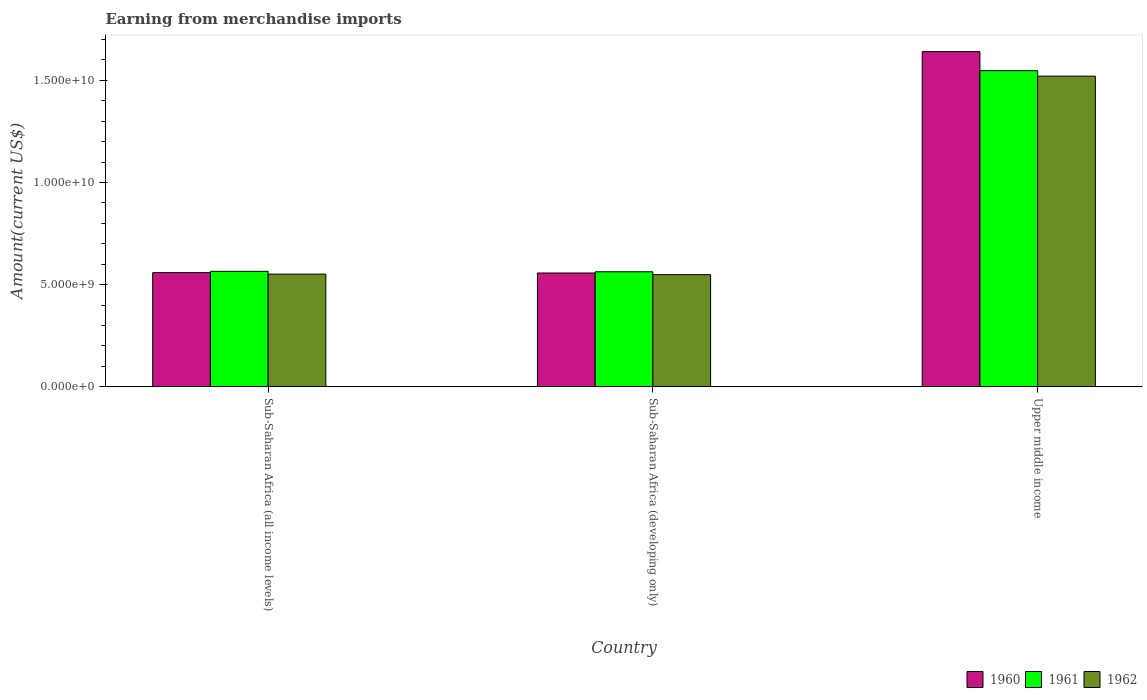How many groups of bars are there?
Provide a succinct answer. 3. How many bars are there on the 1st tick from the left?
Give a very brief answer. 3. How many bars are there on the 2nd tick from the right?
Ensure brevity in your answer.  3. What is the label of the 3rd group of bars from the left?
Keep it short and to the point. Upper middle income. What is the amount earned from merchandise imports in 1960 in Upper middle income?
Make the answer very short. 1.64e+1. Across all countries, what is the maximum amount earned from merchandise imports in 1961?
Provide a short and direct response. 1.55e+1. Across all countries, what is the minimum amount earned from merchandise imports in 1962?
Offer a terse response. 5.49e+09. In which country was the amount earned from merchandise imports in 1961 maximum?
Offer a very short reply. Upper middle income. In which country was the amount earned from merchandise imports in 1962 minimum?
Give a very brief answer. Sub-Saharan Africa (developing only). What is the total amount earned from merchandise imports in 1961 in the graph?
Make the answer very short. 2.68e+1. What is the difference between the amount earned from merchandise imports in 1960 in Sub-Saharan Africa (all income levels) and that in Upper middle income?
Keep it short and to the point. -1.08e+1. What is the difference between the amount earned from merchandise imports in 1962 in Sub-Saharan Africa (all income levels) and the amount earned from merchandise imports in 1961 in Sub-Saharan Africa (developing only)?
Ensure brevity in your answer.  -1.15e+08. What is the average amount earned from merchandise imports in 1961 per country?
Make the answer very short. 8.92e+09. What is the difference between the amount earned from merchandise imports of/in 1962 and amount earned from merchandise imports of/in 1960 in Sub-Saharan Africa (developing only)?
Your answer should be very brief. -8.06e+07. In how many countries, is the amount earned from merchandise imports in 1962 greater than 2000000000 US$?
Give a very brief answer. 3. What is the ratio of the amount earned from merchandise imports in 1961 in Sub-Saharan Africa (all income levels) to that in Upper middle income?
Your answer should be very brief. 0.37. What is the difference between the highest and the second highest amount earned from merchandise imports in 1961?
Keep it short and to the point. 9.82e+09. What is the difference between the highest and the lowest amount earned from merchandise imports in 1962?
Your answer should be compact. 9.71e+09. In how many countries, is the amount earned from merchandise imports in 1961 greater than the average amount earned from merchandise imports in 1961 taken over all countries?
Offer a terse response. 1. Is it the case that in every country, the sum of the amount earned from merchandise imports in 1962 and amount earned from merchandise imports in 1960 is greater than the amount earned from merchandise imports in 1961?
Offer a terse response. Yes. How many countries are there in the graph?
Ensure brevity in your answer.  3. Are the values on the major ticks of Y-axis written in scientific E-notation?
Provide a short and direct response. Yes. What is the title of the graph?
Offer a terse response. Earning from merchandise imports. Does "1976" appear as one of the legend labels in the graph?
Offer a terse response. No. What is the label or title of the X-axis?
Keep it short and to the point. Country. What is the label or title of the Y-axis?
Your answer should be compact. Amount(current US$). What is the Amount(current US$) in 1960 in Sub-Saharan Africa (all income levels)?
Make the answer very short. 5.59e+09. What is the Amount(current US$) of 1961 in Sub-Saharan Africa (all income levels)?
Offer a very short reply. 5.65e+09. What is the Amount(current US$) of 1962 in Sub-Saharan Africa (all income levels)?
Ensure brevity in your answer.  5.52e+09. What is the Amount(current US$) in 1960 in Sub-Saharan Africa (developing only)?
Provide a short and direct response. 5.57e+09. What is the Amount(current US$) of 1961 in Sub-Saharan Africa (developing only)?
Give a very brief answer. 5.63e+09. What is the Amount(current US$) in 1962 in Sub-Saharan Africa (developing only)?
Offer a very short reply. 5.49e+09. What is the Amount(current US$) in 1960 in Upper middle income?
Offer a very short reply. 1.64e+1. What is the Amount(current US$) in 1961 in Upper middle income?
Your response must be concise. 1.55e+1. What is the Amount(current US$) of 1962 in Upper middle income?
Give a very brief answer. 1.52e+1. Across all countries, what is the maximum Amount(current US$) in 1960?
Your response must be concise. 1.64e+1. Across all countries, what is the maximum Amount(current US$) in 1961?
Make the answer very short. 1.55e+1. Across all countries, what is the maximum Amount(current US$) of 1962?
Provide a succinct answer. 1.52e+1. Across all countries, what is the minimum Amount(current US$) of 1960?
Your answer should be compact. 5.57e+09. Across all countries, what is the minimum Amount(current US$) of 1961?
Keep it short and to the point. 5.63e+09. Across all countries, what is the minimum Amount(current US$) of 1962?
Your answer should be compact. 5.49e+09. What is the total Amount(current US$) of 1960 in the graph?
Offer a very short reply. 2.76e+1. What is the total Amount(current US$) in 1961 in the graph?
Provide a succinct answer. 2.68e+1. What is the total Amount(current US$) in 1962 in the graph?
Offer a very short reply. 2.62e+1. What is the difference between the Amount(current US$) of 1960 in Sub-Saharan Africa (all income levels) and that in Sub-Saharan Africa (developing only)?
Ensure brevity in your answer.  1.82e+07. What is the difference between the Amount(current US$) of 1961 in Sub-Saharan Africa (all income levels) and that in Sub-Saharan Africa (developing only)?
Your answer should be compact. 2.08e+07. What is the difference between the Amount(current US$) in 1962 in Sub-Saharan Africa (all income levels) and that in Sub-Saharan Africa (developing only)?
Offer a very short reply. 2.61e+07. What is the difference between the Amount(current US$) of 1960 in Sub-Saharan Africa (all income levels) and that in Upper middle income?
Offer a very short reply. -1.08e+1. What is the difference between the Amount(current US$) of 1961 in Sub-Saharan Africa (all income levels) and that in Upper middle income?
Your answer should be compact. -9.82e+09. What is the difference between the Amount(current US$) in 1962 in Sub-Saharan Africa (all income levels) and that in Upper middle income?
Keep it short and to the point. -9.69e+09. What is the difference between the Amount(current US$) of 1960 in Sub-Saharan Africa (developing only) and that in Upper middle income?
Give a very brief answer. -1.08e+1. What is the difference between the Amount(current US$) in 1961 in Sub-Saharan Africa (developing only) and that in Upper middle income?
Offer a very short reply. -9.84e+09. What is the difference between the Amount(current US$) of 1962 in Sub-Saharan Africa (developing only) and that in Upper middle income?
Your answer should be very brief. -9.71e+09. What is the difference between the Amount(current US$) of 1960 in Sub-Saharan Africa (all income levels) and the Amount(current US$) of 1961 in Sub-Saharan Africa (developing only)?
Provide a succinct answer. -4.19e+07. What is the difference between the Amount(current US$) in 1960 in Sub-Saharan Africa (all income levels) and the Amount(current US$) in 1962 in Sub-Saharan Africa (developing only)?
Your answer should be very brief. 9.88e+07. What is the difference between the Amount(current US$) of 1961 in Sub-Saharan Africa (all income levels) and the Amount(current US$) of 1962 in Sub-Saharan Africa (developing only)?
Keep it short and to the point. 1.62e+08. What is the difference between the Amount(current US$) in 1960 in Sub-Saharan Africa (all income levels) and the Amount(current US$) in 1961 in Upper middle income?
Give a very brief answer. -9.88e+09. What is the difference between the Amount(current US$) in 1960 in Sub-Saharan Africa (all income levels) and the Amount(current US$) in 1962 in Upper middle income?
Ensure brevity in your answer.  -9.61e+09. What is the difference between the Amount(current US$) of 1961 in Sub-Saharan Africa (all income levels) and the Amount(current US$) of 1962 in Upper middle income?
Your response must be concise. -9.55e+09. What is the difference between the Amount(current US$) of 1960 in Sub-Saharan Africa (developing only) and the Amount(current US$) of 1961 in Upper middle income?
Provide a succinct answer. -9.90e+09. What is the difference between the Amount(current US$) of 1960 in Sub-Saharan Africa (developing only) and the Amount(current US$) of 1962 in Upper middle income?
Keep it short and to the point. -9.63e+09. What is the difference between the Amount(current US$) in 1961 in Sub-Saharan Africa (developing only) and the Amount(current US$) in 1962 in Upper middle income?
Your answer should be very brief. -9.57e+09. What is the average Amount(current US$) of 1960 per country?
Provide a short and direct response. 9.19e+09. What is the average Amount(current US$) of 1961 per country?
Your response must be concise. 8.92e+09. What is the average Amount(current US$) in 1962 per country?
Your answer should be compact. 8.74e+09. What is the difference between the Amount(current US$) of 1960 and Amount(current US$) of 1961 in Sub-Saharan Africa (all income levels)?
Provide a succinct answer. -6.28e+07. What is the difference between the Amount(current US$) of 1960 and Amount(current US$) of 1962 in Sub-Saharan Africa (all income levels)?
Your response must be concise. 7.27e+07. What is the difference between the Amount(current US$) of 1961 and Amount(current US$) of 1962 in Sub-Saharan Africa (all income levels)?
Provide a short and direct response. 1.35e+08. What is the difference between the Amount(current US$) of 1960 and Amount(current US$) of 1961 in Sub-Saharan Africa (developing only)?
Make the answer very short. -6.01e+07. What is the difference between the Amount(current US$) in 1960 and Amount(current US$) in 1962 in Sub-Saharan Africa (developing only)?
Offer a terse response. 8.06e+07. What is the difference between the Amount(current US$) of 1961 and Amount(current US$) of 1962 in Sub-Saharan Africa (developing only)?
Keep it short and to the point. 1.41e+08. What is the difference between the Amount(current US$) in 1960 and Amount(current US$) in 1961 in Upper middle income?
Keep it short and to the point. 9.31e+08. What is the difference between the Amount(current US$) in 1960 and Amount(current US$) in 1962 in Upper middle income?
Offer a terse response. 1.20e+09. What is the difference between the Amount(current US$) in 1961 and Amount(current US$) in 1962 in Upper middle income?
Offer a very short reply. 2.67e+08. What is the ratio of the Amount(current US$) of 1960 in Sub-Saharan Africa (all income levels) to that in Sub-Saharan Africa (developing only)?
Provide a succinct answer. 1. What is the ratio of the Amount(current US$) of 1961 in Sub-Saharan Africa (all income levels) to that in Sub-Saharan Africa (developing only)?
Offer a terse response. 1. What is the ratio of the Amount(current US$) of 1962 in Sub-Saharan Africa (all income levels) to that in Sub-Saharan Africa (developing only)?
Offer a very short reply. 1. What is the ratio of the Amount(current US$) of 1960 in Sub-Saharan Africa (all income levels) to that in Upper middle income?
Offer a very short reply. 0.34. What is the ratio of the Amount(current US$) of 1961 in Sub-Saharan Africa (all income levels) to that in Upper middle income?
Your answer should be compact. 0.37. What is the ratio of the Amount(current US$) in 1962 in Sub-Saharan Africa (all income levels) to that in Upper middle income?
Ensure brevity in your answer.  0.36. What is the ratio of the Amount(current US$) in 1960 in Sub-Saharan Africa (developing only) to that in Upper middle income?
Your answer should be compact. 0.34. What is the ratio of the Amount(current US$) of 1961 in Sub-Saharan Africa (developing only) to that in Upper middle income?
Offer a very short reply. 0.36. What is the ratio of the Amount(current US$) in 1962 in Sub-Saharan Africa (developing only) to that in Upper middle income?
Provide a short and direct response. 0.36. What is the difference between the highest and the second highest Amount(current US$) in 1960?
Offer a terse response. 1.08e+1. What is the difference between the highest and the second highest Amount(current US$) of 1961?
Ensure brevity in your answer.  9.82e+09. What is the difference between the highest and the second highest Amount(current US$) in 1962?
Your response must be concise. 9.69e+09. What is the difference between the highest and the lowest Amount(current US$) of 1960?
Provide a short and direct response. 1.08e+1. What is the difference between the highest and the lowest Amount(current US$) in 1961?
Your answer should be very brief. 9.84e+09. What is the difference between the highest and the lowest Amount(current US$) in 1962?
Offer a very short reply. 9.71e+09. 